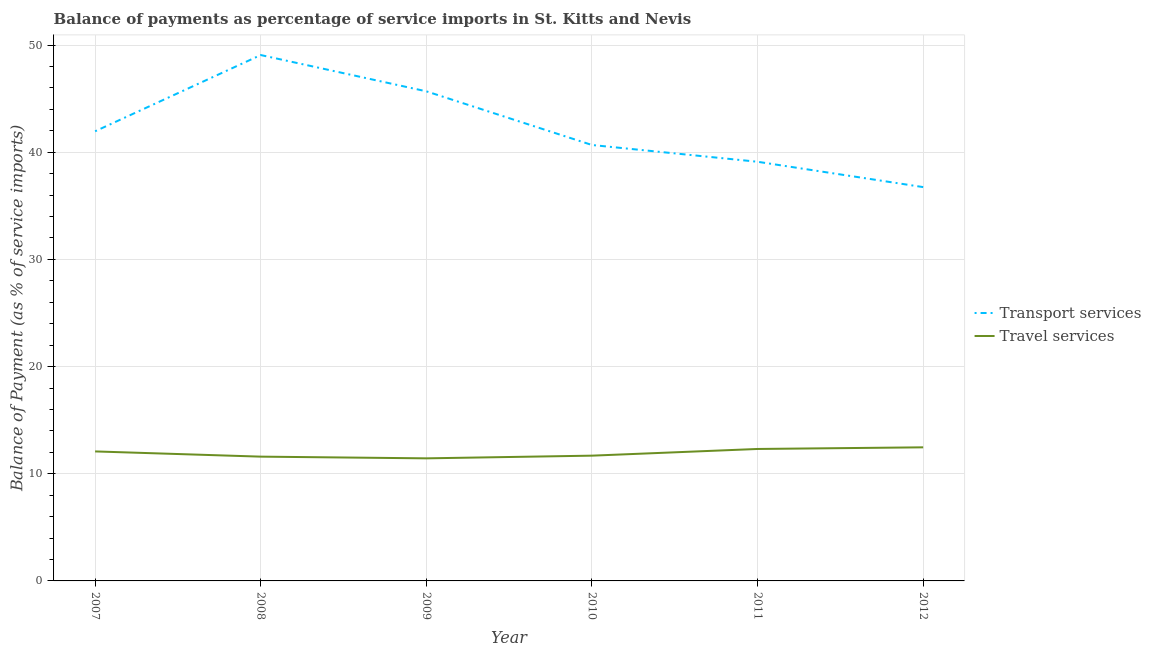How many different coloured lines are there?
Keep it short and to the point. 2. What is the balance of payments of transport services in 2007?
Offer a very short reply. 41.96. Across all years, what is the maximum balance of payments of travel services?
Keep it short and to the point. 12.47. Across all years, what is the minimum balance of payments of travel services?
Your response must be concise. 11.44. In which year was the balance of payments of transport services maximum?
Keep it short and to the point. 2008. What is the total balance of payments of transport services in the graph?
Make the answer very short. 253.26. What is the difference between the balance of payments of transport services in 2009 and that in 2011?
Offer a terse response. 6.57. What is the difference between the balance of payments of travel services in 2008 and the balance of payments of transport services in 2009?
Your response must be concise. -34.09. What is the average balance of payments of travel services per year?
Offer a terse response. 11.93. In the year 2010, what is the difference between the balance of payments of transport services and balance of payments of travel services?
Make the answer very short. 28.99. What is the ratio of the balance of payments of transport services in 2009 to that in 2011?
Your answer should be compact. 1.17. Is the difference between the balance of payments of transport services in 2008 and 2010 greater than the difference between the balance of payments of travel services in 2008 and 2010?
Provide a succinct answer. Yes. What is the difference between the highest and the second highest balance of payments of transport services?
Offer a terse response. 3.39. What is the difference between the highest and the lowest balance of payments of transport services?
Offer a very short reply. 12.32. In how many years, is the balance of payments of transport services greater than the average balance of payments of transport services taken over all years?
Keep it short and to the point. 2. Does the balance of payments of transport services monotonically increase over the years?
Offer a very short reply. No. Is the balance of payments of transport services strictly greater than the balance of payments of travel services over the years?
Make the answer very short. Yes. Is the balance of payments of travel services strictly less than the balance of payments of transport services over the years?
Keep it short and to the point. Yes. How many lines are there?
Offer a terse response. 2. What is the difference between two consecutive major ticks on the Y-axis?
Give a very brief answer. 10. Are the values on the major ticks of Y-axis written in scientific E-notation?
Offer a terse response. No. What is the title of the graph?
Give a very brief answer. Balance of payments as percentage of service imports in St. Kitts and Nevis. What is the label or title of the X-axis?
Keep it short and to the point. Year. What is the label or title of the Y-axis?
Offer a terse response. Balance of Payment (as % of service imports). What is the Balance of Payment (as % of service imports) of Transport services in 2007?
Your response must be concise. 41.96. What is the Balance of Payment (as % of service imports) in Travel services in 2007?
Provide a short and direct response. 12.08. What is the Balance of Payment (as % of service imports) in Transport services in 2008?
Offer a terse response. 49.07. What is the Balance of Payment (as % of service imports) in Travel services in 2008?
Your answer should be very brief. 11.6. What is the Balance of Payment (as % of service imports) in Transport services in 2009?
Make the answer very short. 45.69. What is the Balance of Payment (as % of service imports) of Travel services in 2009?
Give a very brief answer. 11.44. What is the Balance of Payment (as % of service imports) of Transport services in 2010?
Keep it short and to the point. 40.68. What is the Balance of Payment (as % of service imports) in Travel services in 2010?
Provide a short and direct response. 11.69. What is the Balance of Payment (as % of service imports) in Transport services in 2011?
Your answer should be very brief. 39.11. What is the Balance of Payment (as % of service imports) in Travel services in 2011?
Offer a terse response. 12.31. What is the Balance of Payment (as % of service imports) in Transport services in 2012?
Your response must be concise. 36.75. What is the Balance of Payment (as % of service imports) of Travel services in 2012?
Your response must be concise. 12.47. Across all years, what is the maximum Balance of Payment (as % of service imports) in Transport services?
Provide a short and direct response. 49.07. Across all years, what is the maximum Balance of Payment (as % of service imports) in Travel services?
Ensure brevity in your answer.  12.47. Across all years, what is the minimum Balance of Payment (as % of service imports) of Transport services?
Your answer should be compact. 36.75. Across all years, what is the minimum Balance of Payment (as % of service imports) in Travel services?
Your response must be concise. 11.44. What is the total Balance of Payment (as % of service imports) in Transport services in the graph?
Ensure brevity in your answer.  253.26. What is the total Balance of Payment (as % of service imports) in Travel services in the graph?
Provide a succinct answer. 71.59. What is the difference between the Balance of Payment (as % of service imports) of Transport services in 2007 and that in 2008?
Provide a succinct answer. -7.11. What is the difference between the Balance of Payment (as % of service imports) in Travel services in 2007 and that in 2008?
Keep it short and to the point. 0.49. What is the difference between the Balance of Payment (as % of service imports) in Transport services in 2007 and that in 2009?
Keep it short and to the point. -3.73. What is the difference between the Balance of Payment (as % of service imports) of Travel services in 2007 and that in 2009?
Your answer should be compact. 0.65. What is the difference between the Balance of Payment (as % of service imports) in Transport services in 2007 and that in 2010?
Your response must be concise. 1.28. What is the difference between the Balance of Payment (as % of service imports) in Travel services in 2007 and that in 2010?
Your answer should be compact. 0.39. What is the difference between the Balance of Payment (as % of service imports) in Transport services in 2007 and that in 2011?
Provide a short and direct response. 2.85. What is the difference between the Balance of Payment (as % of service imports) of Travel services in 2007 and that in 2011?
Your response must be concise. -0.23. What is the difference between the Balance of Payment (as % of service imports) of Transport services in 2007 and that in 2012?
Give a very brief answer. 5.21. What is the difference between the Balance of Payment (as % of service imports) of Travel services in 2007 and that in 2012?
Provide a short and direct response. -0.38. What is the difference between the Balance of Payment (as % of service imports) of Transport services in 2008 and that in 2009?
Offer a terse response. 3.39. What is the difference between the Balance of Payment (as % of service imports) in Travel services in 2008 and that in 2009?
Offer a terse response. 0.16. What is the difference between the Balance of Payment (as % of service imports) of Transport services in 2008 and that in 2010?
Provide a short and direct response. 8.39. What is the difference between the Balance of Payment (as % of service imports) of Travel services in 2008 and that in 2010?
Your answer should be very brief. -0.09. What is the difference between the Balance of Payment (as % of service imports) of Transport services in 2008 and that in 2011?
Your answer should be very brief. 9.96. What is the difference between the Balance of Payment (as % of service imports) in Travel services in 2008 and that in 2011?
Your answer should be very brief. -0.72. What is the difference between the Balance of Payment (as % of service imports) in Transport services in 2008 and that in 2012?
Keep it short and to the point. 12.32. What is the difference between the Balance of Payment (as % of service imports) in Travel services in 2008 and that in 2012?
Provide a succinct answer. -0.87. What is the difference between the Balance of Payment (as % of service imports) of Transport services in 2009 and that in 2010?
Give a very brief answer. 5.01. What is the difference between the Balance of Payment (as % of service imports) in Travel services in 2009 and that in 2010?
Make the answer very short. -0.25. What is the difference between the Balance of Payment (as % of service imports) in Transport services in 2009 and that in 2011?
Offer a terse response. 6.57. What is the difference between the Balance of Payment (as % of service imports) in Travel services in 2009 and that in 2011?
Provide a short and direct response. -0.88. What is the difference between the Balance of Payment (as % of service imports) in Transport services in 2009 and that in 2012?
Make the answer very short. 8.94. What is the difference between the Balance of Payment (as % of service imports) of Travel services in 2009 and that in 2012?
Your answer should be very brief. -1.03. What is the difference between the Balance of Payment (as % of service imports) in Transport services in 2010 and that in 2011?
Your answer should be compact. 1.56. What is the difference between the Balance of Payment (as % of service imports) in Travel services in 2010 and that in 2011?
Provide a short and direct response. -0.62. What is the difference between the Balance of Payment (as % of service imports) in Transport services in 2010 and that in 2012?
Provide a short and direct response. 3.93. What is the difference between the Balance of Payment (as % of service imports) in Travel services in 2010 and that in 2012?
Make the answer very short. -0.78. What is the difference between the Balance of Payment (as % of service imports) of Transport services in 2011 and that in 2012?
Make the answer very short. 2.36. What is the difference between the Balance of Payment (as % of service imports) of Travel services in 2011 and that in 2012?
Provide a succinct answer. -0.15. What is the difference between the Balance of Payment (as % of service imports) in Transport services in 2007 and the Balance of Payment (as % of service imports) in Travel services in 2008?
Give a very brief answer. 30.36. What is the difference between the Balance of Payment (as % of service imports) in Transport services in 2007 and the Balance of Payment (as % of service imports) in Travel services in 2009?
Your response must be concise. 30.52. What is the difference between the Balance of Payment (as % of service imports) in Transport services in 2007 and the Balance of Payment (as % of service imports) in Travel services in 2010?
Ensure brevity in your answer.  30.27. What is the difference between the Balance of Payment (as % of service imports) of Transport services in 2007 and the Balance of Payment (as % of service imports) of Travel services in 2011?
Make the answer very short. 29.65. What is the difference between the Balance of Payment (as % of service imports) of Transport services in 2007 and the Balance of Payment (as % of service imports) of Travel services in 2012?
Offer a terse response. 29.49. What is the difference between the Balance of Payment (as % of service imports) of Transport services in 2008 and the Balance of Payment (as % of service imports) of Travel services in 2009?
Make the answer very short. 37.63. What is the difference between the Balance of Payment (as % of service imports) of Transport services in 2008 and the Balance of Payment (as % of service imports) of Travel services in 2010?
Make the answer very short. 37.38. What is the difference between the Balance of Payment (as % of service imports) of Transport services in 2008 and the Balance of Payment (as % of service imports) of Travel services in 2011?
Your response must be concise. 36.76. What is the difference between the Balance of Payment (as % of service imports) in Transport services in 2008 and the Balance of Payment (as % of service imports) in Travel services in 2012?
Offer a terse response. 36.61. What is the difference between the Balance of Payment (as % of service imports) of Transport services in 2009 and the Balance of Payment (as % of service imports) of Travel services in 2010?
Provide a succinct answer. 34. What is the difference between the Balance of Payment (as % of service imports) of Transport services in 2009 and the Balance of Payment (as % of service imports) of Travel services in 2011?
Offer a terse response. 33.37. What is the difference between the Balance of Payment (as % of service imports) of Transport services in 2009 and the Balance of Payment (as % of service imports) of Travel services in 2012?
Offer a terse response. 33.22. What is the difference between the Balance of Payment (as % of service imports) of Transport services in 2010 and the Balance of Payment (as % of service imports) of Travel services in 2011?
Keep it short and to the point. 28.36. What is the difference between the Balance of Payment (as % of service imports) of Transport services in 2010 and the Balance of Payment (as % of service imports) of Travel services in 2012?
Your answer should be very brief. 28.21. What is the difference between the Balance of Payment (as % of service imports) in Transport services in 2011 and the Balance of Payment (as % of service imports) in Travel services in 2012?
Provide a short and direct response. 26.65. What is the average Balance of Payment (as % of service imports) of Transport services per year?
Ensure brevity in your answer.  42.21. What is the average Balance of Payment (as % of service imports) of Travel services per year?
Offer a terse response. 11.93. In the year 2007, what is the difference between the Balance of Payment (as % of service imports) of Transport services and Balance of Payment (as % of service imports) of Travel services?
Keep it short and to the point. 29.87. In the year 2008, what is the difference between the Balance of Payment (as % of service imports) of Transport services and Balance of Payment (as % of service imports) of Travel services?
Your answer should be very brief. 37.48. In the year 2009, what is the difference between the Balance of Payment (as % of service imports) in Transport services and Balance of Payment (as % of service imports) in Travel services?
Give a very brief answer. 34.25. In the year 2010, what is the difference between the Balance of Payment (as % of service imports) of Transport services and Balance of Payment (as % of service imports) of Travel services?
Your answer should be very brief. 28.99. In the year 2011, what is the difference between the Balance of Payment (as % of service imports) of Transport services and Balance of Payment (as % of service imports) of Travel services?
Give a very brief answer. 26.8. In the year 2012, what is the difference between the Balance of Payment (as % of service imports) in Transport services and Balance of Payment (as % of service imports) in Travel services?
Offer a very short reply. 24.28. What is the ratio of the Balance of Payment (as % of service imports) of Transport services in 2007 to that in 2008?
Your answer should be compact. 0.85. What is the ratio of the Balance of Payment (as % of service imports) of Travel services in 2007 to that in 2008?
Offer a terse response. 1.04. What is the ratio of the Balance of Payment (as % of service imports) in Transport services in 2007 to that in 2009?
Make the answer very short. 0.92. What is the ratio of the Balance of Payment (as % of service imports) of Travel services in 2007 to that in 2009?
Ensure brevity in your answer.  1.06. What is the ratio of the Balance of Payment (as % of service imports) in Transport services in 2007 to that in 2010?
Give a very brief answer. 1.03. What is the ratio of the Balance of Payment (as % of service imports) in Travel services in 2007 to that in 2010?
Your answer should be very brief. 1.03. What is the ratio of the Balance of Payment (as % of service imports) of Transport services in 2007 to that in 2011?
Your answer should be compact. 1.07. What is the ratio of the Balance of Payment (as % of service imports) in Travel services in 2007 to that in 2011?
Provide a short and direct response. 0.98. What is the ratio of the Balance of Payment (as % of service imports) of Transport services in 2007 to that in 2012?
Your answer should be very brief. 1.14. What is the ratio of the Balance of Payment (as % of service imports) in Travel services in 2007 to that in 2012?
Make the answer very short. 0.97. What is the ratio of the Balance of Payment (as % of service imports) in Transport services in 2008 to that in 2009?
Keep it short and to the point. 1.07. What is the ratio of the Balance of Payment (as % of service imports) in Travel services in 2008 to that in 2009?
Your answer should be compact. 1.01. What is the ratio of the Balance of Payment (as % of service imports) of Transport services in 2008 to that in 2010?
Your answer should be very brief. 1.21. What is the ratio of the Balance of Payment (as % of service imports) in Transport services in 2008 to that in 2011?
Your response must be concise. 1.25. What is the ratio of the Balance of Payment (as % of service imports) in Travel services in 2008 to that in 2011?
Your answer should be very brief. 0.94. What is the ratio of the Balance of Payment (as % of service imports) in Transport services in 2008 to that in 2012?
Offer a terse response. 1.34. What is the ratio of the Balance of Payment (as % of service imports) of Travel services in 2008 to that in 2012?
Make the answer very short. 0.93. What is the ratio of the Balance of Payment (as % of service imports) in Transport services in 2009 to that in 2010?
Ensure brevity in your answer.  1.12. What is the ratio of the Balance of Payment (as % of service imports) in Travel services in 2009 to that in 2010?
Offer a very short reply. 0.98. What is the ratio of the Balance of Payment (as % of service imports) in Transport services in 2009 to that in 2011?
Offer a very short reply. 1.17. What is the ratio of the Balance of Payment (as % of service imports) of Travel services in 2009 to that in 2011?
Ensure brevity in your answer.  0.93. What is the ratio of the Balance of Payment (as % of service imports) in Transport services in 2009 to that in 2012?
Your answer should be compact. 1.24. What is the ratio of the Balance of Payment (as % of service imports) in Travel services in 2009 to that in 2012?
Your answer should be compact. 0.92. What is the ratio of the Balance of Payment (as % of service imports) in Transport services in 2010 to that in 2011?
Give a very brief answer. 1.04. What is the ratio of the Balance of Payment (as % of service imports) in Travel services in 2010 to that in 2011?
Ensure brevity in your answer.  0.95. What is the ratio of the Balance of Payment (as % of service imports) of Transport services in 2010 to that in 2012?
Your response must be concise. 1.11. What is the ratio of the Balance of Payment (as % of service imports) in Travel services in 2010 to that in 2012?
Provide a succinct answer. 0.94. What is the ratio of the Balance of Payment (as % of service imports) in Transport services in 2011 to that in 2012?
Your answer should be very brief. 1.06. What is the ratio of the Balance of Payment (as % of service imports) of Travel services in 2011 to that in 2012?
Give a very brief answer. 0.99. What is the difference between the highest and the second highest Balance of Payment (as % of service imports) of Transport services?
Provide a short and direct response. 3.39. What is the difference between the highest and the second highest Balance of Payment (as % of service imports) of Travel services?
Offer a very short reply. 0.15. What is the difference between the highest and the lowest Balance of Payment (as % of service imports) of Transport services?
Your response must be concise. 12.32. What is the difference between the highest and the lowest Balance of Payment (as % of service imports) of Travel services?
Keep it short and to the point. 1.03. 